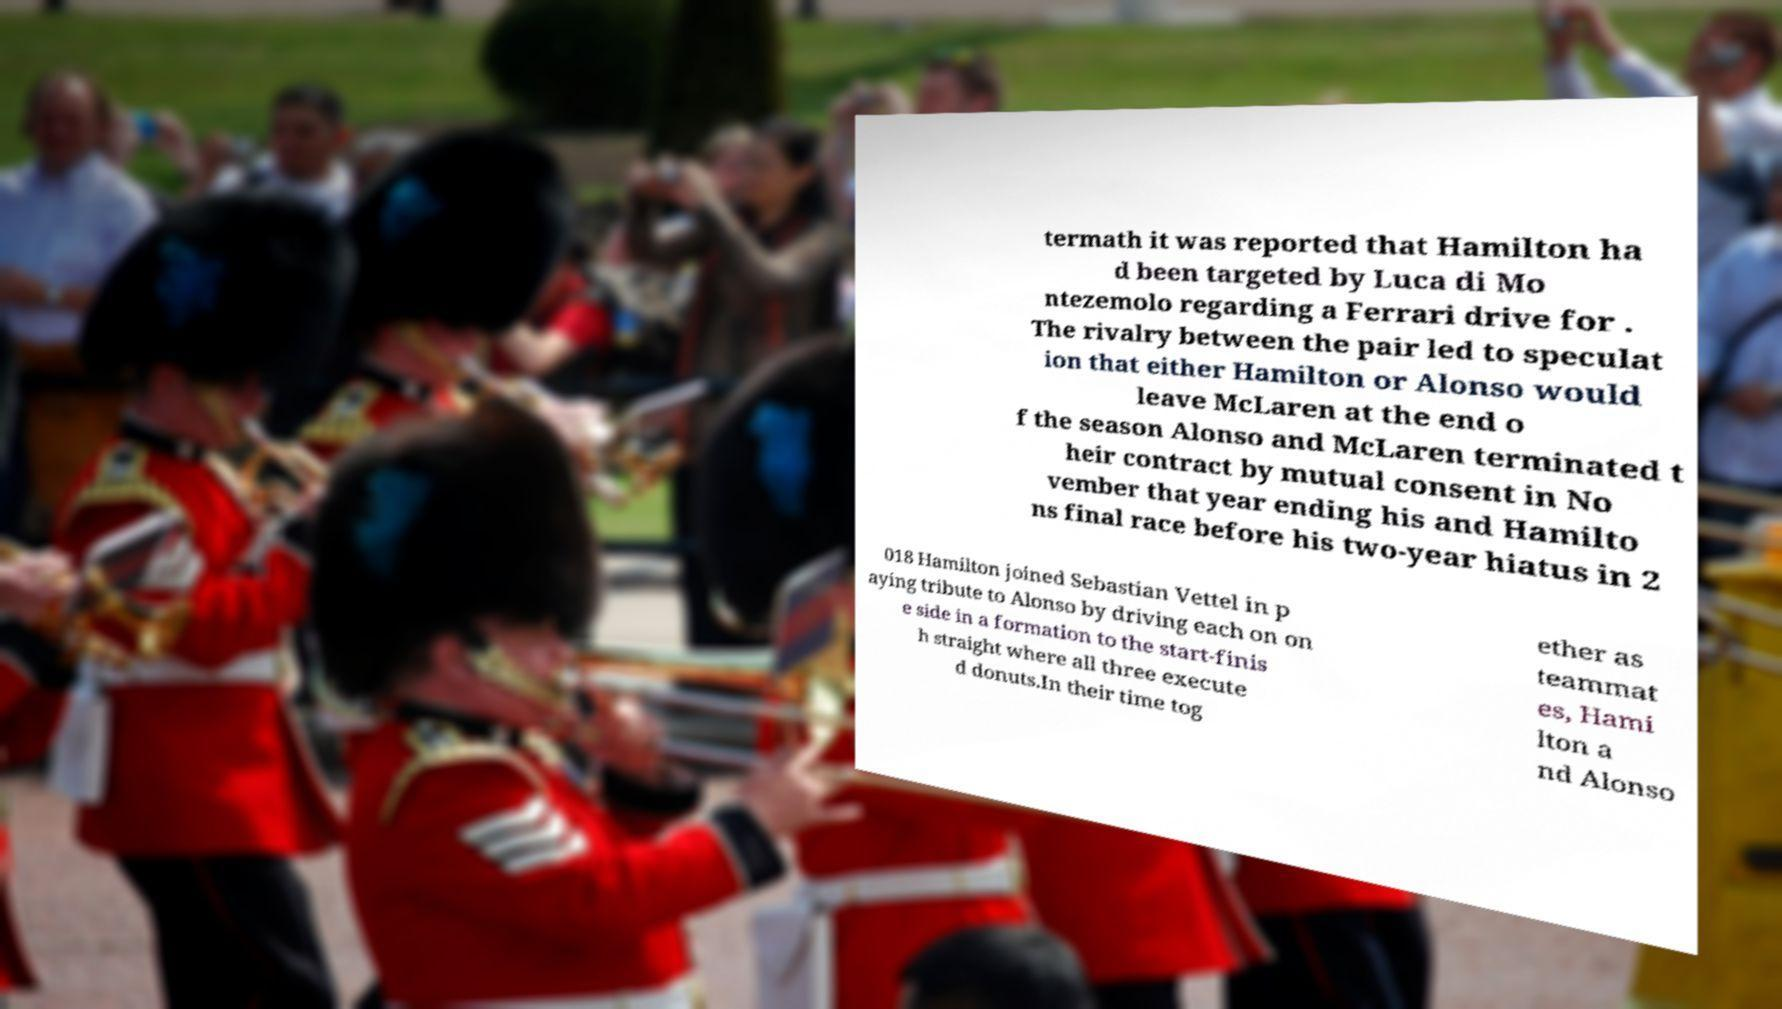Can you read and provide the text displayed in the image?This photo seems to have some interesting text. Can you extract and type it out for me? termath it was reported that Hamilton ha d been targeted by Luca di Mo ntezemolo regarding a Ferrari drive for . The rivalry between the pair led to speculat ion that either Hamilton or Alonso would leave McLaren at the end o f the season Alonso and McLaren terminated t heir contract by mutual consent in No vember that year ending his and Hamilto ns final race before his two-year hiatus in 2 018 Hamilton joined Sebastian Vettel in p aying tribute to Alonso by driving each on on e side in a formation to the start-finis h straight where all three execute d donuts.In their time tog ether as teammat es, Hami lton a nd Alonso 